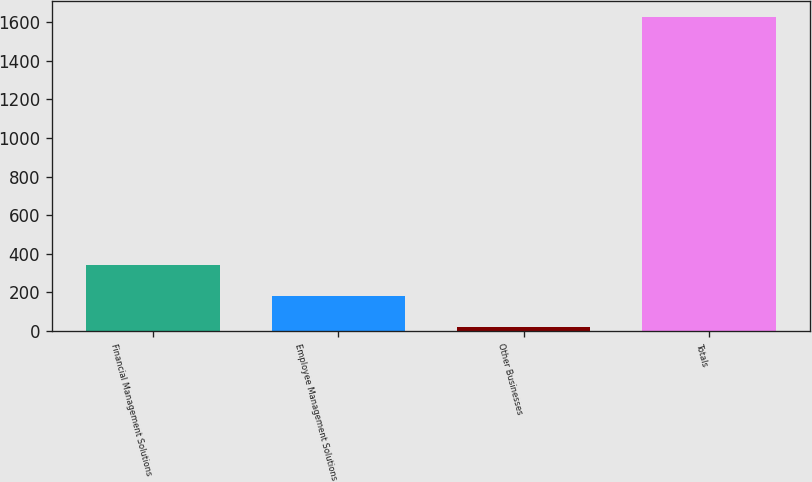Convert chart to OTSL. <chart><loc_0><loc_0><loc_500><loc_500><bar_chart><fcel>Financial Management Solutions<fcel>Employee Management Solutions<fcel>Other Businesses<fcel>Totals<nl><fcel>339.6<fcel>178.8<fcel>18<fcel>1626<nl></chart> 